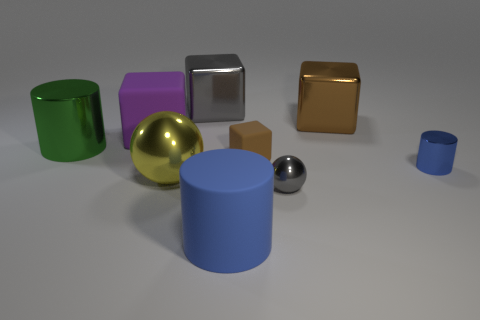Add 1 cyan metal cylinders. How many objects exist? 10 Subtract all blocks. How many objects are left? 5 Add 8 small gray metallic spheres. How many small gray metallic spheres are left? 9 Add 7 metal balls. How many metal balls exist? 9 Subtract 1 gray spheres. How many objects are left? 8 Subtract all gray metal spheres. Subtract all small gray shiny objects. How many objects are left? 7 